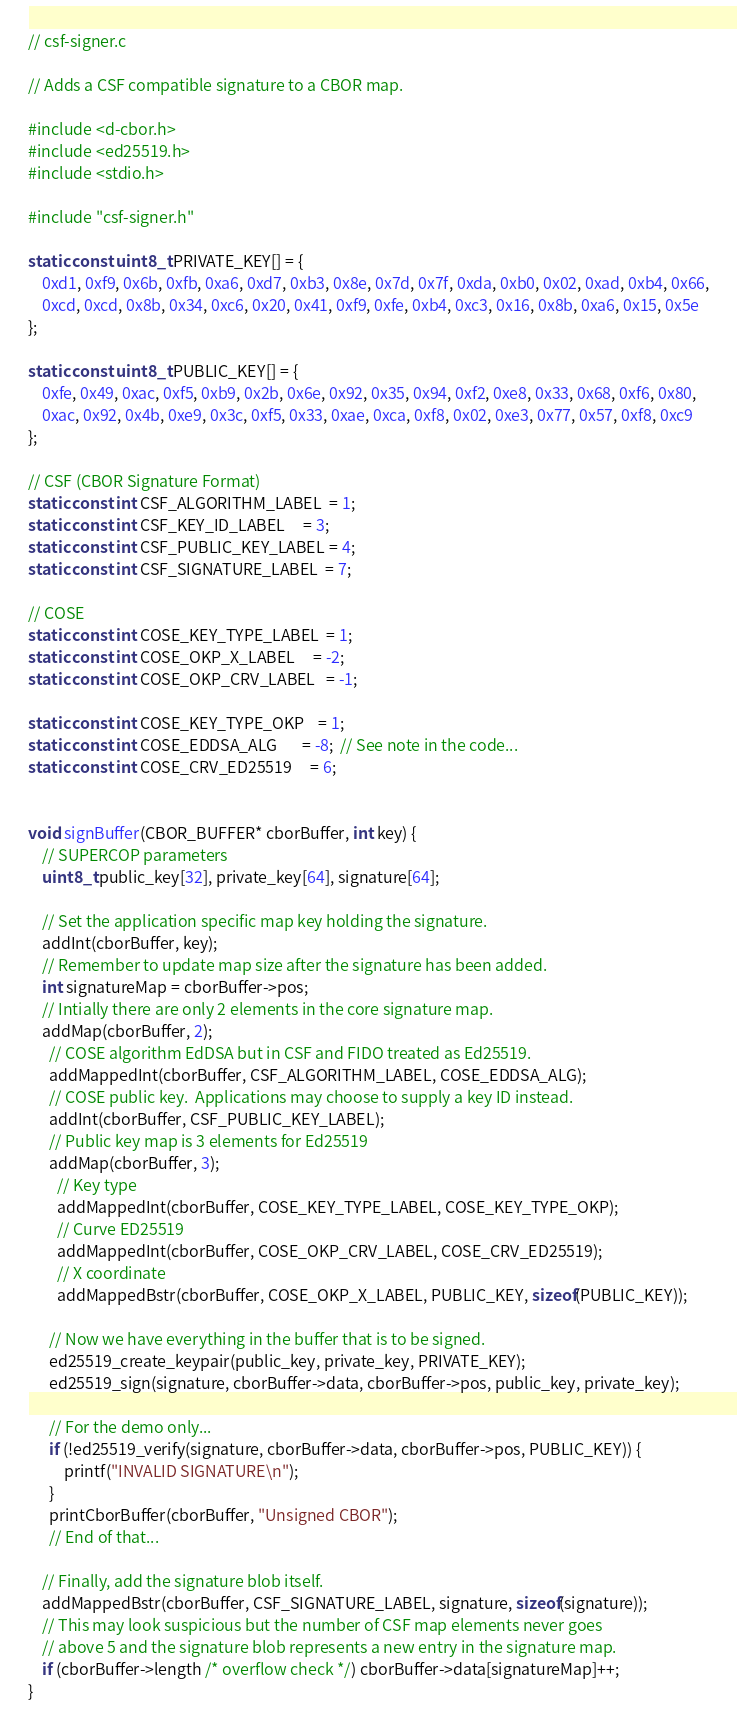Convert code to text. <code><loc_0><loc_0><loc_500><loc_500><_C_>// csf-signer.c

// Adds a CSF compatible signature to a CBOR map.

#include <d-cbor.h>
#include <ed25519.h>
#include <stdio.h>

#include "csf-signer.h"

static const uint8_t PRIVATE_KEY[] = {
    0xd1, 0xf9, 0x6b, 0xfb, 0xa6, 0xd7, 0xb3, 0x8e, 0x7d, 0x7f, 0xda, 0xb0, 0x02, 0xad, 0xb4, 0x66,
    0xcd, 0xcd, 0x8b, 0x34, 0xc6, 0x20, 0x41, 0xf9, 0xfe, 0xb4, 0xc3, 0x16, 0x8b, 0xa6, 0x15, 0x5e
};

static const uint8_t PUBLIC_KEY[] = {
    0xfe, 0x49, 0xac, 0xf5, 0xb9, 0x2b, 0x6e, 0x92, 0x35, 0x94, 0xf2, 0xe8, 0x33, 0x68, 0xf6, 0x80,
    0xac, 0x92, 0x4b, 0xe9, 0x3c, 0xf5, 0x33, 0xae, 0xca, 0xf8, 0x02, 0xe3, 0x77, 0x57, 0xf8, 0xc9
};

// CSF (CBOR Signature Format)
static const int CSF_ALGORITHM_LABEL  = 1;
static const int CSF_KEY_ID_LABEL     = 3;
static const int CSF_PUBLIC_KEY_LABEL = 4;
static const int CSF_SIGNATURE_LABEL  = 7;

// COSE
static const int COSE_KEY_TYPE_LABEL  = 1;
static const int COSE_OKP_X_LABEL     = -2;
static const int COSE_OKP_CRV_LABEL   = -1;

static const int COSE_KEY_TYPE_OKP    = 1;
static const int COSE_EDDSA_ALG       = -8;  // See note in the code...
static const int COSE_CRV_ED25519     = 6;


void signBuffer(CBOR_BUFFER* cborBuffer, int key) {
    // SUPERCOP parameters
    uint8_t public_key[32], private_key[64], signature[64];
 
    // Set the application specific map key holding the signature.
    addInt(cborBuffer, key);
    // Remember to update map size after the signature has been added.
    int signatureMap = cborBuffer->pos;
    // Intially there are only 2 elements in the core signature map.
    addMap(cborBuffer, 2);
      // COSE algorithm EdDSA but in CSF and FIDO treated as Ed25519.
      addMappedInt(cborBuffer, CSF_ALGORITHM_LABEL, COSE_EDDSA_ALG);
      // COSE public key.  Applications may choose to supply a key ID instead.
      addInt(cborBuffer, CSF_PUBLIC_KEY_LABEL);
      // Public key map is 3 elements for Ed25519
      addMap(cborBuffer, 3);
        // Key type
        addMappedInt(cborBuffer, COSE_KEY_TYPE_LABEL, COSE_KEY_TYPE_OKP);
        // Curve ED25519
        addMappedInt(cborBuffer, COSE_OKP_CRV_LABEL, COSE_CRV_ED25519);
        // X coordinate
        addMappedBstr(cborBuffer, COSE_OKP_X_LABEL, PUBLIC_KEY, sizeof(PUBLIC_KEY));

      // Now we have everything in the buffer that is to be signed.
      ed25519_create_keypair(public_key, private_key, PRIVATE_KEY);
      ed25519_sign(signature, cborBuffer->data, cborBuffer->pos, public_key, private_key);

      // For the demo only...
      if (!ed25519_verify(signature, cborBuffer->data, cborBuffer->pos, PUBLIC_KEY)) {
          printf("INVALID SIGNATURE\n");
      }
      printCborBuffer(cborBuffer, "Unsigned CBOR");
      // End of that...

    // Finally, add the signature blob itself.
    addMappedBstr(cborBuffer, CSF_SIGNATURE_LABEL, signature, sizeof(signature));
    // This may look suspicious but the number of CSF map elements never goes
    // above 5 and the signature blob represents a new entry in the signature map.
    if (cborBuffer->length /* overflow check */) cborBuffer->data[signatureMap]++;
}</code> 